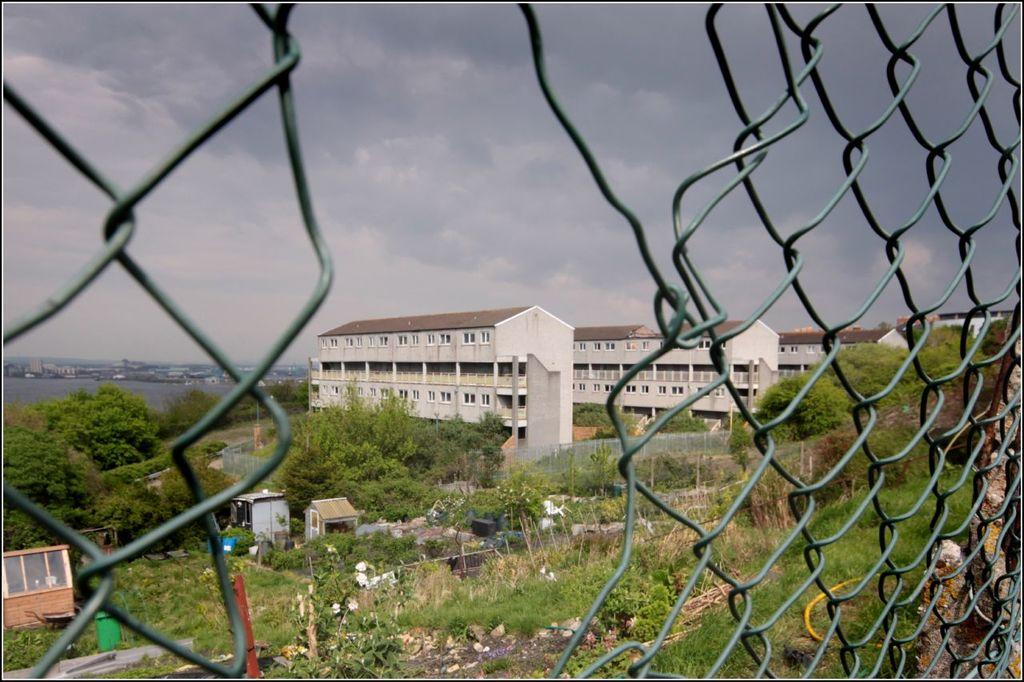What type of barrier can be seen in the image? There is a wire fence in the image. What type of natural elements are present in the image? There are trees and plants in the image. What type of structures are visible in the image? There are houses in the image. What type of landscape feature can be seen in the image? There is water visible in the image. What is visible in the background of the image? The sky is visible in the background of the image. Where is the playground located in the image? There is no playground present in the image. Can you describe the protest taking place in the image? There is no protest present in the image. 